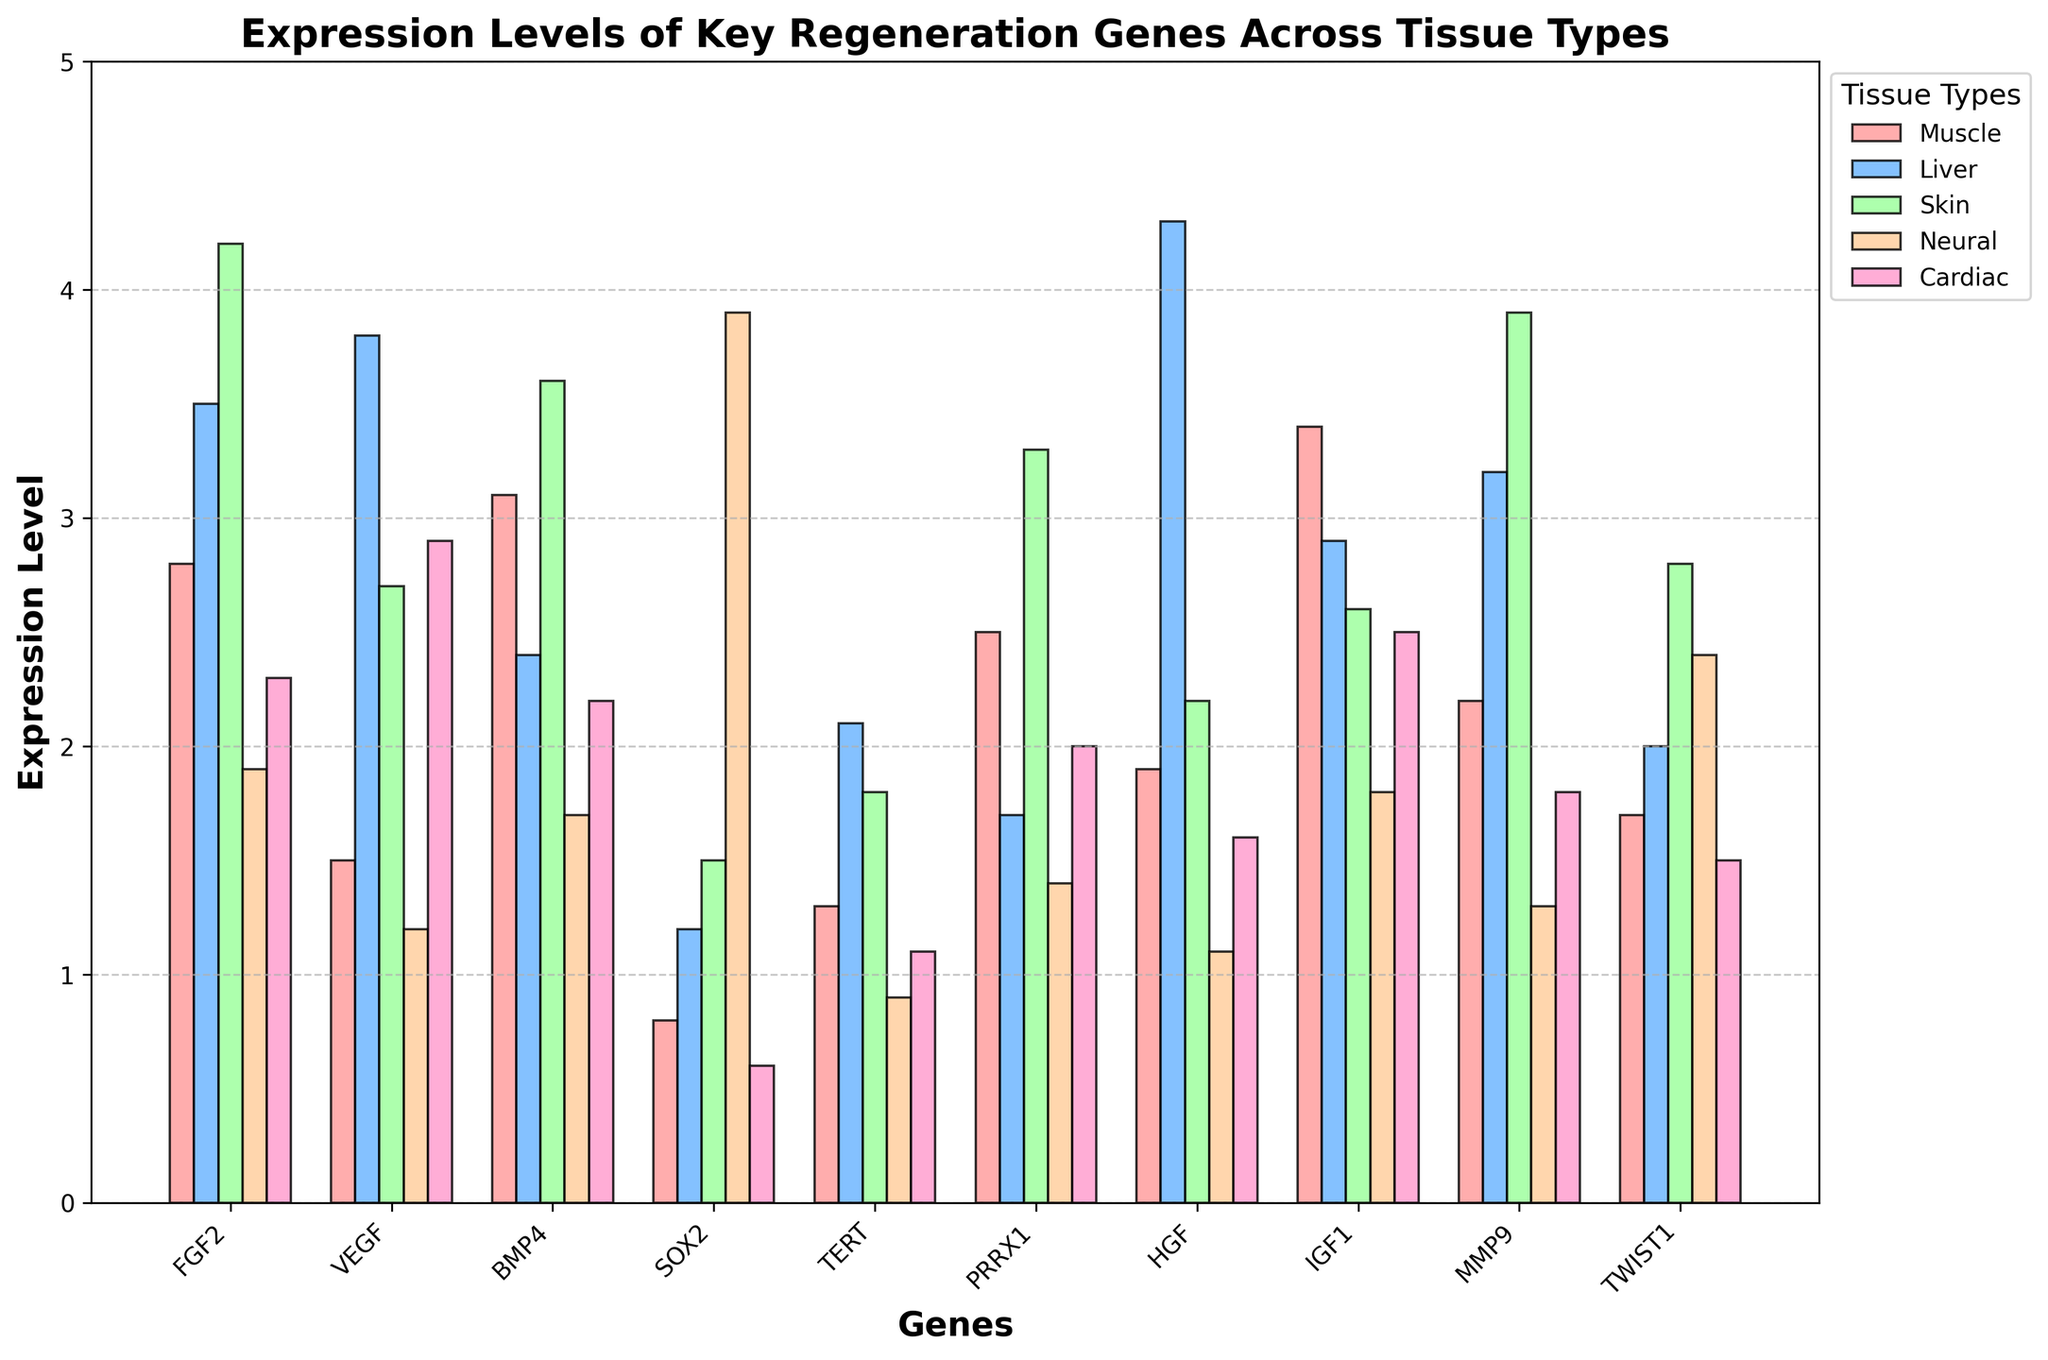Which gene has the highest expression level in Skin tissue? Look for the tallest bar in the Skin tissue category and identify the corresponding gene. The tallest bar in Skin tissue corresponds to gene FGF2 with an expression level of 4.2.
Answer: FGF2 Which tissue type has the lowest expression level of SOX2? Identify the bar for SOX2 in each tissue type and find the shortest one. The shortest bar for SOX2 is in the Cardiac tissue with an expression level of 0.6.
Answer: Cardiac How does the expression level of BMP4 compare between Liver and Neural tissue? Find the bars for BMP4 in Liver and Neural tissues and compare their heights. The BMP4 expression level is 2.4 for Liver and 1.7 for Neural. Liver has a higher expression level than Neural.
Answer: Liver is higher What is the sum of expression levels of TERT across all tissue types? Add the expression levels of TERT for all tissue types: Muscle (1.3), Liver (2.1), Skin (1.8), Neural (0.9), Cardiac (1.1). Sum is 1.3 + 2.1 + 1.8 + 0.9 + 1.1 = 7.2.
Answer: 7.2 Which tissue type shows the highest expression level of HGF? Look at the bars for HGF across all tissue types and find the tallest one. The tallest bar is for Liver with an expression level of 4.3.
Answer: Liver What is the average expression level of IGF1 across Muscle and Skin tissues? Sum the expression levels of IGF1 in Muscle (3.4) and Skin (2.6) and then divide by 2: (3.4 + 2.6) / 2 = 3.0.
Answer: 3.0 Is the expression level of PRRX1 in Neural tissue greater than its expression level in Liver tissue? Compare the heights of the bars for PRRX1 in Neural (1.4) and Liver (1.7). The expression level in Neural is less than in Liver.
Answer: No What is the difference between the expression levels of VEGF in Liver and Muscle tissues? Subtract the expression level of VEGF in Muscle (1.5) from that in Liver (3.8): 3.8 - 1.5 = 2.3.
Answer: 2.3 